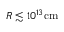Convert formula to latex. <formula><loc_0><loc_0><loc_500><loc_500>R \lesssim 1 0 ^ { 1 3 } c m</formula> 